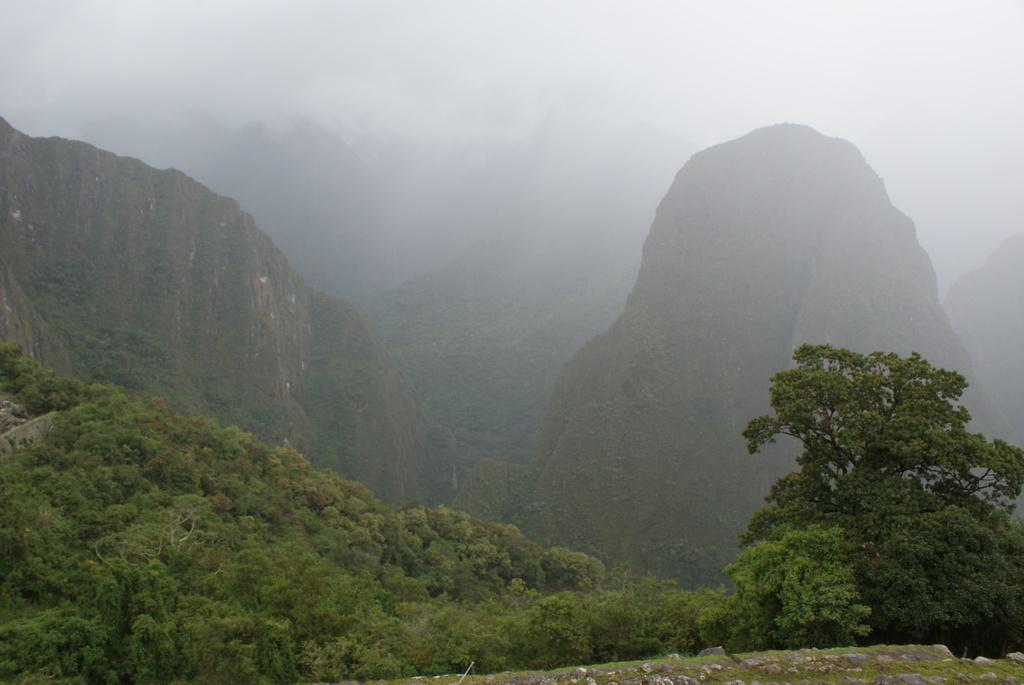What type of vegetation can be seen in the image? There are trees in the image. What geographical features are visible in the image? There are hills visible in the image. What atmospheric condition is present in the image? Fog is present in the image. Can you describe the stranger's locket in the image? There is no stranger or locket present in the image. What type of company is depicted in the image? The image does not show any company or group of people; it features trees, hills, and fog. 